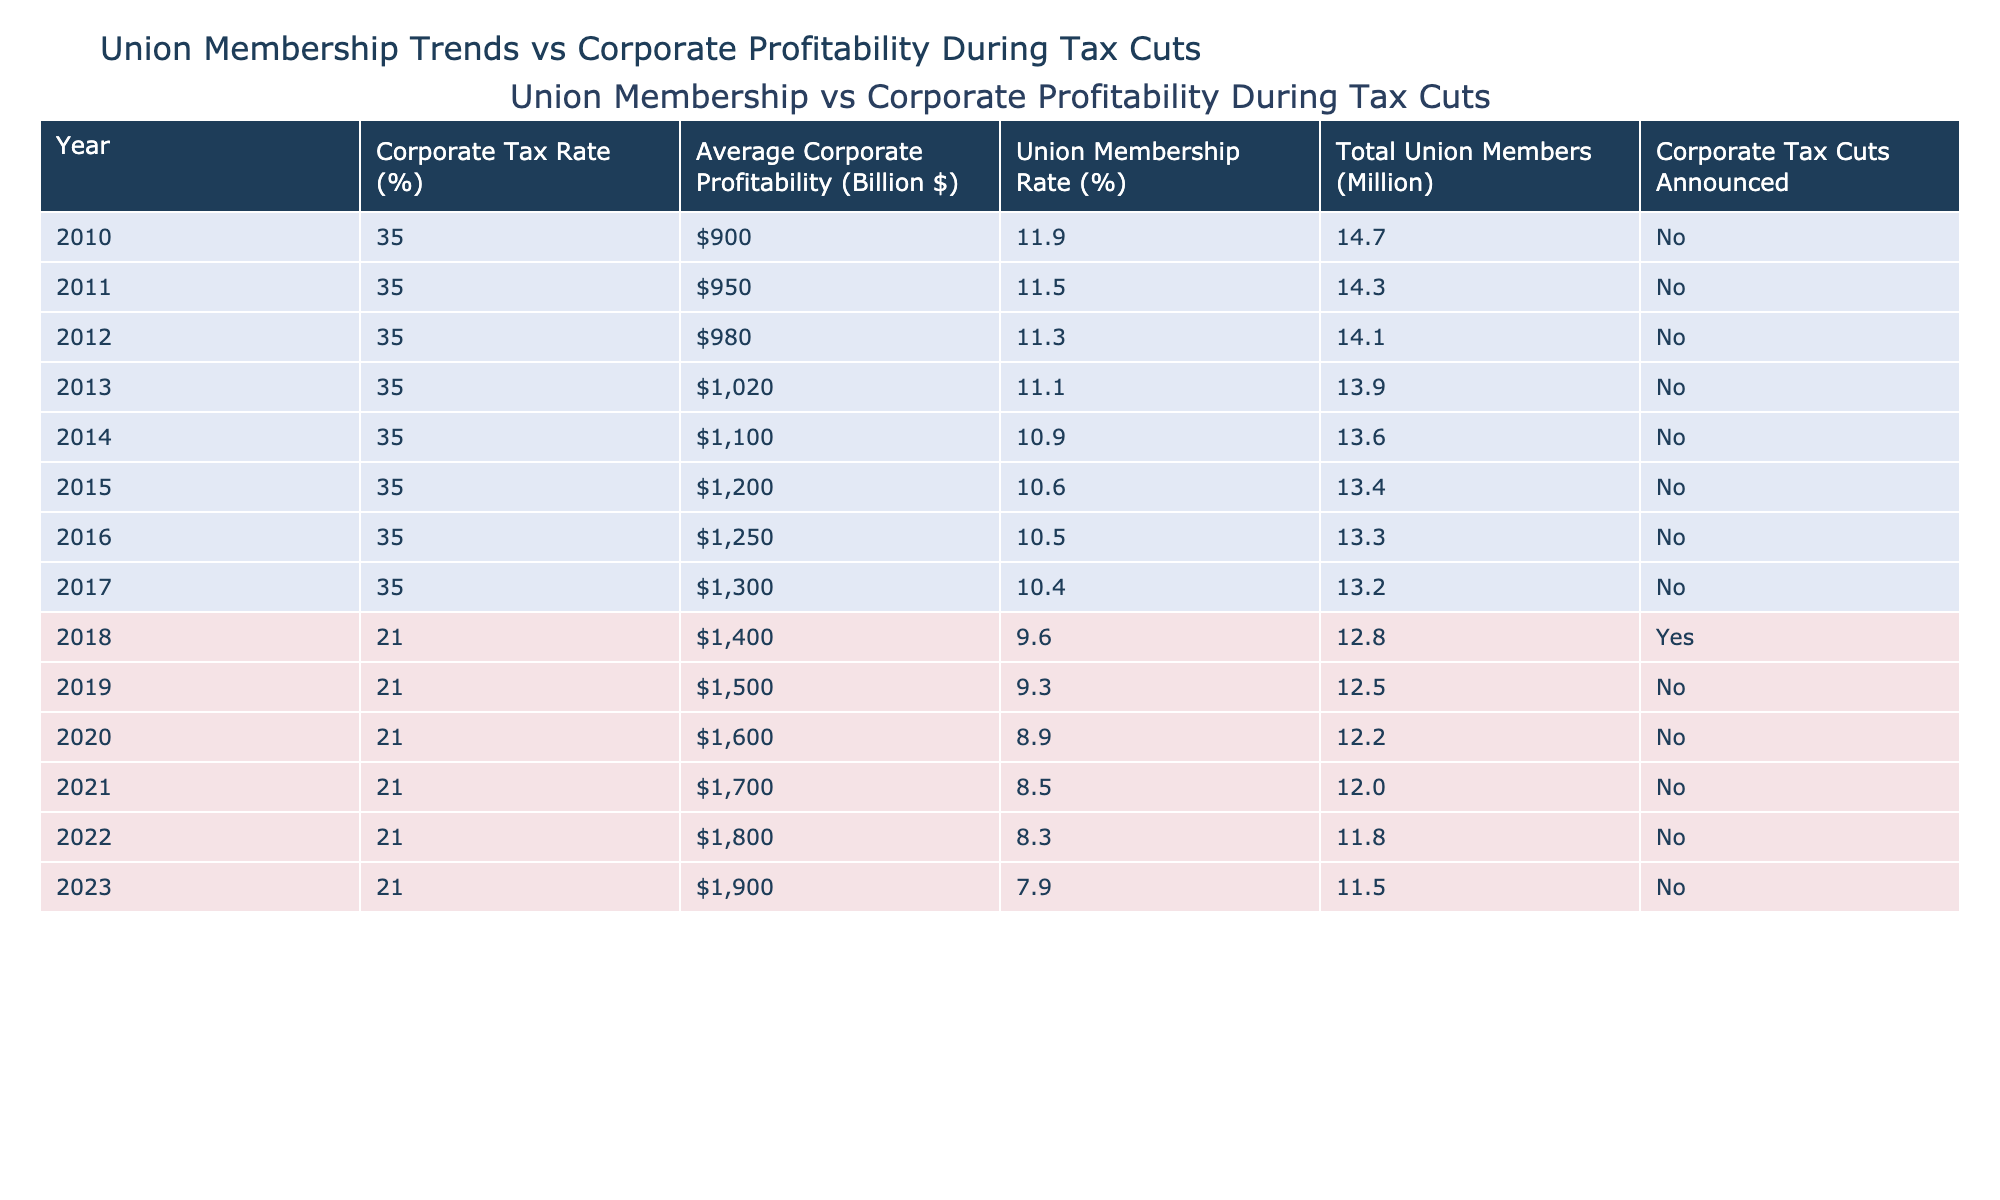What was the corporate tax rate in 2017? Looking at the table, the corporate tax rate for the year 2017 is clearly indicated in that row. It shows 35%.
Answer: 35% What is the average corporate profitability in 2021? By checking the row for the year 2021, we find that the average corporate profitability is $1,700 billion.
Answer: $1,700 billion In which year was the union membership rate the lowest? We examine the union membership rates across all years, identifying that 7.9% in 2023 is the lowest membership rate.
Answer: 2023 How much did corporate profitability increase from 2010 to 2013? The average corporate profitability in 2010 was $900 billion and in 2013 it was $1,020 billion. The increase is calculated as $1,020 - $900 = $120 billion.
Answer: $120 billion Did corporate tax cuts result in increased union membership? Observing the table, there was a tax cut announced in 2018, and the union membership dropped to 9.6% from 10.4% in 2017. This indicates a decrease in union membership with tax cuts.
Answer: No What was the change in total union members from 2010 to 2023? In 2010, total union members were 14.7 million and in 2023 they dropped to 11.5 million. The change is calculated as 11.5 - 14.7 = -3.2 million members, indicating a loss.
Answer: -3.2 million members Which year had the highest corporate profitability and what was the tax rate? The highest corporate profitability occurred in 2023 at $1,900 billion, and the tax rate for that year was 21%.
Answer: 21% What is the average union membership rate between 2010 and 2017? Adding the union membership rates from 2010 (11.9%), 2011 (11.5%), 2012 (11.3%), 2013 (11.1%), 2014 (10.9%), 2015 (10.6%), 2016 (10.5%), and 2017 (10.4%) gives us a total of 76.8%. Dividing by the 8 years gives us an average of 9.6%.
Answer: 10.6% Was there a tax cut on corporate rates in the years 2015 through 2017? Looking at the table, from 2010 to 2017 the tax rate remained at 35%, and there were no corporate tax cuts announced during those years.
Answer: No Analyze the relationship between decrease in the corporate tax rate and change in union membership from 2018 to 2023. The corporate tax rate decreased from 35% in 2017 to 21% in 2018. However, union membership continued to decline from 9.6% in 2018 to 7.9% in 2023. This indicates a negative relationship between the tax rate decrease and union membership.
Answer: Negative relationship 